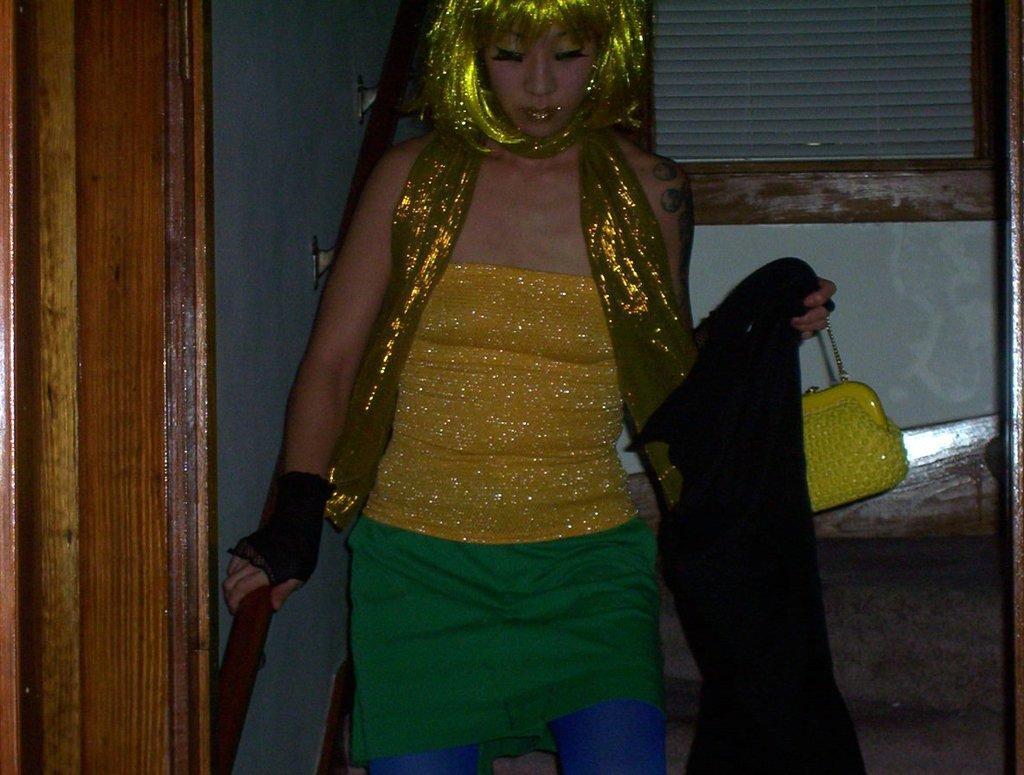In one or two sentences, can you explain what this image depicts? This image consists of a woman holding a bag. The hair is in green color. To the left, there is a door. In the background, there is a wall. 